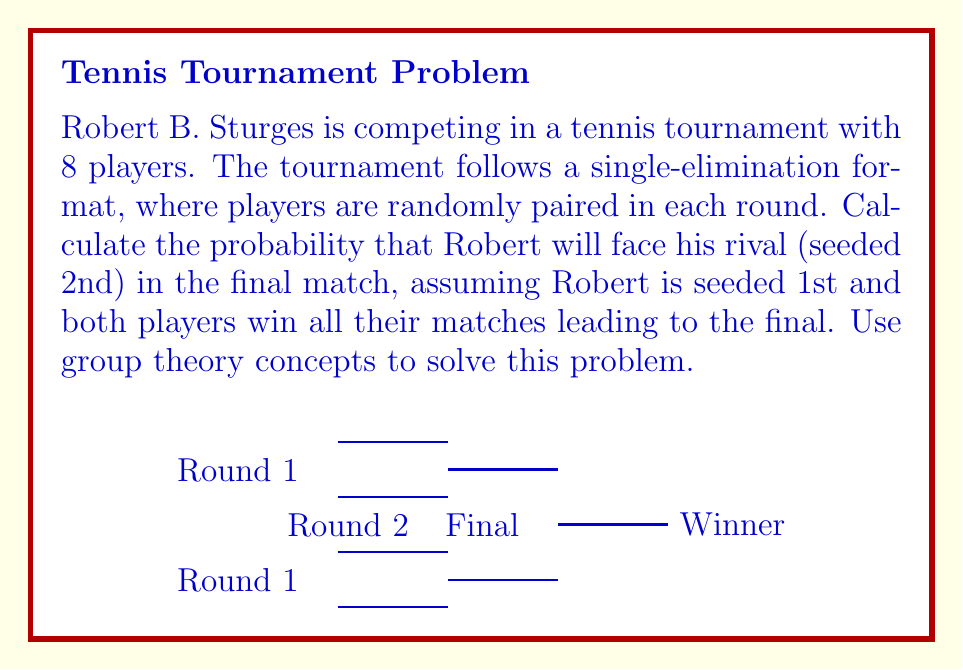Can you solve this math problem? Let's approach this step-by-step using group theory concepts:

1) First, we need to understand that the tournament structure forms a symmetry group. The group of permutations of the 8 players forms the symmetric group $S_8$.

2) Robert (1st seed) and his rival (2nd seed) are fixed points in this group, as they are predetermined to be on opposite sides of the bracket.

3) The remaining 6 players can be arranged in any order. This forms a subgroup isomorphic to $S_6$.

4) For Robert to meet his rival in the final, the bracket must be arranged such that:
   - Robert wins his side (beating 3 players)
   - His rival wins the other side (beating 3 players)

5) The probability of this happening is equivalent to counting the number of favorable arrangements and dividing by the total number of possible arrangements.

6) Total number of arrangements: $|S_6| = 6! = 720$

7) Favorable arrangements:
   - Robert's side: 3 players can be arranged in $3! = 6$ ways
   - Rival's side: 3 players can be arranged in $3! = 6$ ways
   - Total favorable arrangements: $6 \times 6 = 36$

8) Probability = $\frac{\text{Favorable outcomes}}{\text{Total outcomes}} = \frac{36}{720} = \frac{1}{20} = 0.05$

Therefore, the probability that Robert will face his rival in the final is $\frac{1}{20}$ or 5%.
Answer: $\frac{1}{20}$ 